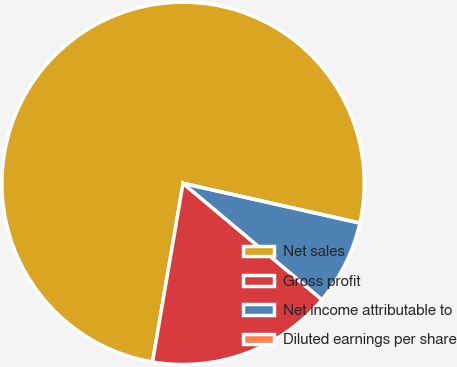Convert chart to OTSL. <chart><loc_0><loc_0><loc_500><loc_500><pie_chart><fcel>Net sales<fcel>Gross profit<fcel>Net income attributable to<fcel>Diluted earnings per share<nl><fcel>75.82%<fcel>16.6%<fcel>7.58%<fcel>0.0%<nl></chart> 